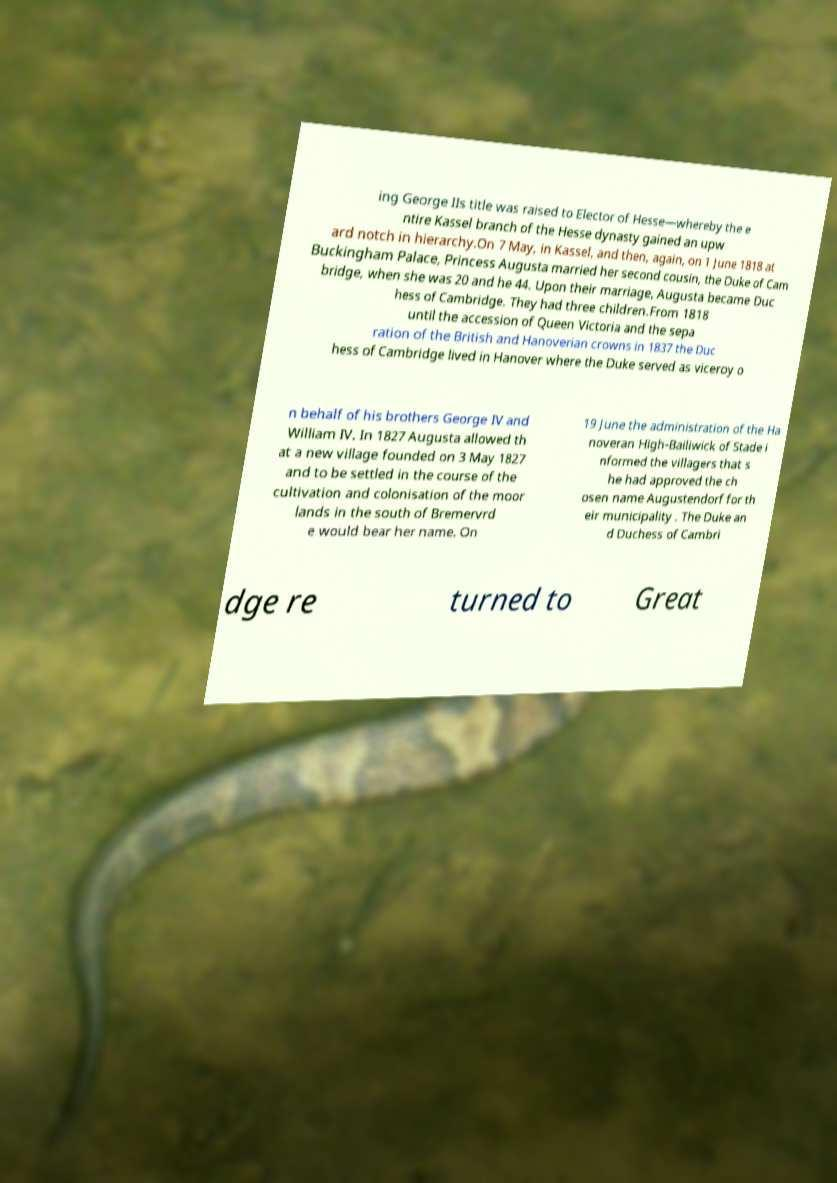I need the written content from this picture converted into text. Can you do that? ing George IIs title was raised to Elector of Hesse—whereby the e ntire Kassel branch of the Hesse dynasty gained an upw ard notch in hierarchy.On 7 May, in Kassel, and then, again, on 1 June 1818 at Buckingham Palace, Princess Augusta married her second cousin, the Duke of Cam bridge, when she was 20 and he 44. Upon their marriage, Augusta became Duc hess of Cambridge. They had three children.From 1818 until the accession of Queen Victoria and the sepa ration of the British and Hanoverian crowns in 1837 the Duc hess of Cambridge lived in Hanover where the Duke served as viceroy o n behalf of his brothers George IV and William IV. In 1827 Augusta allowed th at a new village founded on 3 May 1827 and to be settled in the course of the cultivation and colonisation of the moor lands in the south of Bremervrd e would bear her name. On 19 June the administration of the Ha noveran High-Bailiwick of Stade i nformed the villagers that s he had approved the ch osen name Augustendorf for th eir municipality . The Duke an d Duchess of Cambri dge re turned to Great 